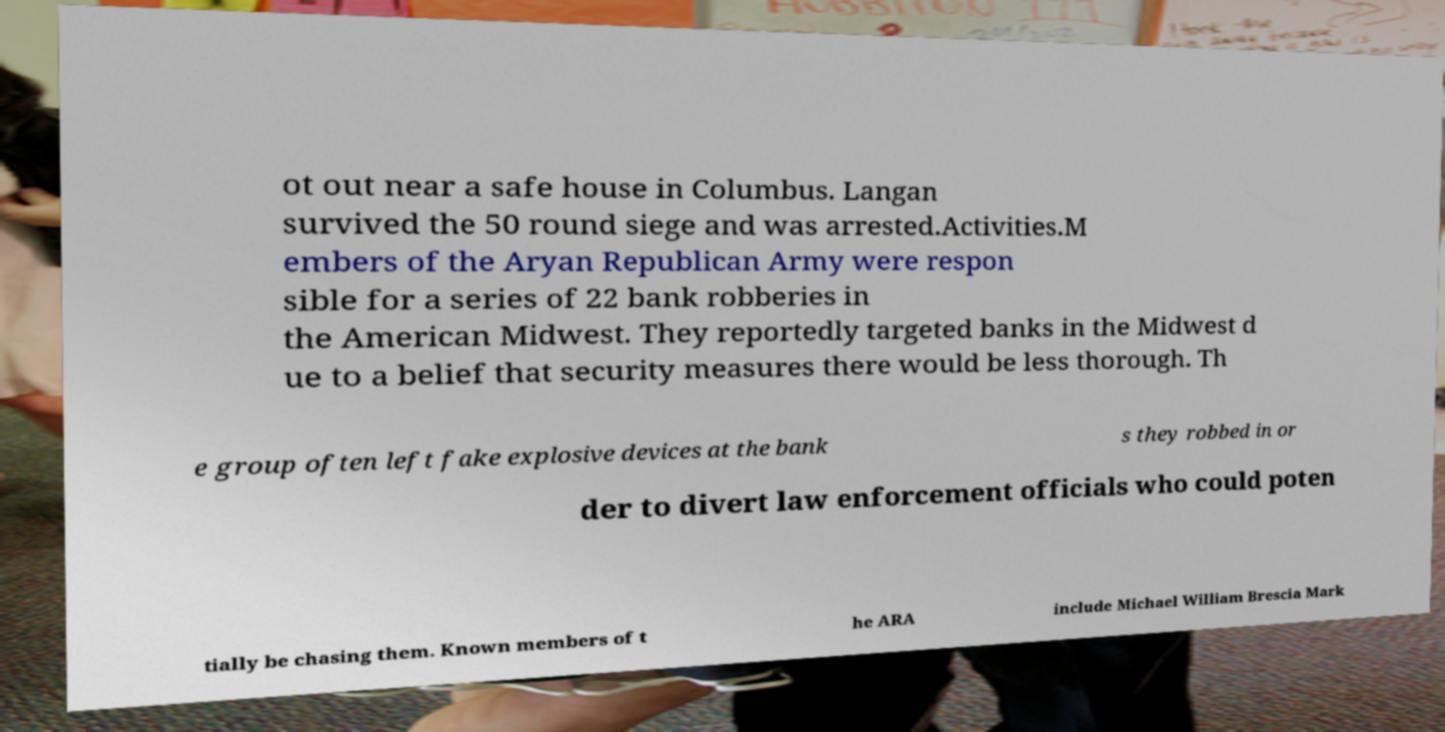What messages or text are displayed in this image? I need them in a readable, typed format. ot out near a safe house in Columbus. Langan survived the 50 round siege and was arrested.Activities.M embers of the Aryan Republican Army were respon sible for a series of 22 bank robberies in the American Midwest. They reportedly targeted banks in the Midwest d ue to a belief that security measures there would be less thorough. Th e group often left fake explosive devices at the bank s they robbed in or der to divert law enforcement officials who could poten tially be chasing them. Known members of t he ARA include Michael William Brescia Mark 